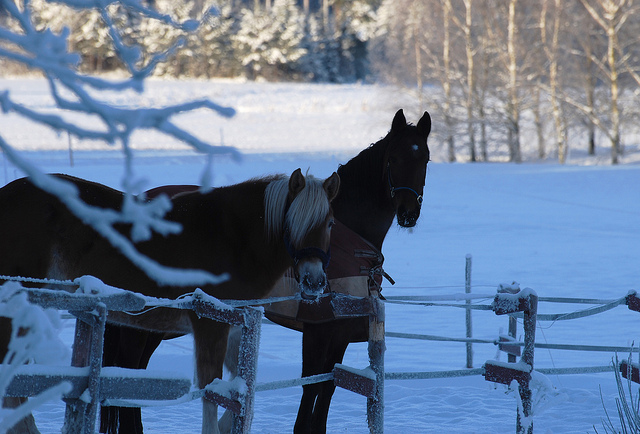What details can you tell me about the surrounding environment? The environment appears serene and quite cold, covered in a blanket of snow. The trees in the distance are without leaves, indicating it's likely winter. The clear blue sky suggests a crisp but possibly sunny day. Could you guess the time of day? Considering the apparent direction and quality of the light, with the shadows cast on the snow, it could be mid-morning or late afternoon. The precise time is difficult to determine without further context. 